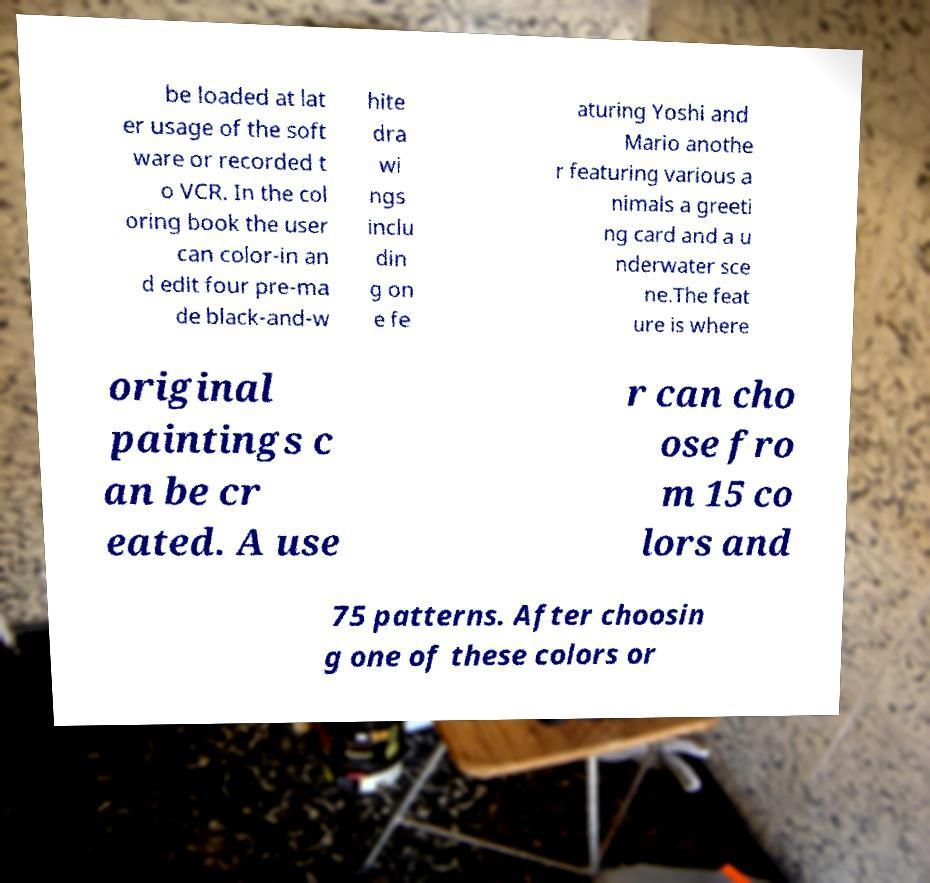Please read and relay the text visible in this image. What does it say? be loaded at lat er usage of the soft ware or recorded t o VCR. In the col oring book the user can color-in an d edit four pre-ma de black-and-w hite dra wi ngs inclu din g on e fe aturing Yoshi and Mario anothe r featuring various a nimals a greeti ng card and a u nderwater sce ne.The feat ure is where original paintings c an be cr eated. A use r can cho ose fro m 15 co lors and 75 patterns. After choosin g one of these colors or 